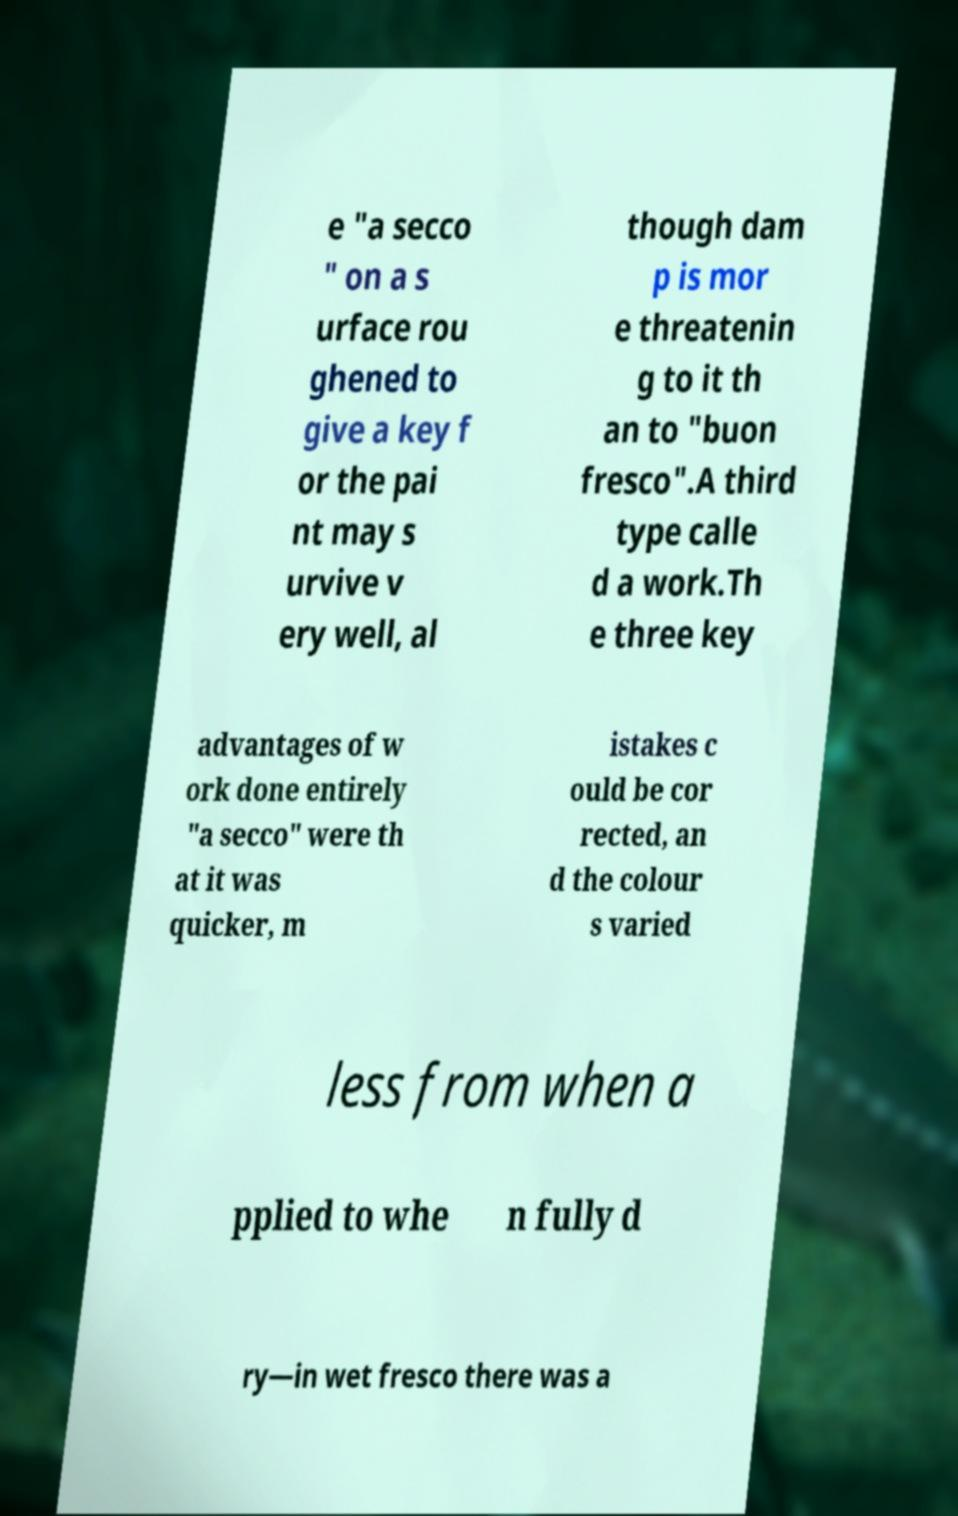There's text embedded in this image that I need extracted. Can you transcribe it verbatim? e "a secco " on a s urface rou ghened to give a key f or the pai nt may s urvive v ery well, al though dam p is mor e threatenin g to it th an to "buon fresco".A third type calle d a work.Th e three key advantages of w ork done entirely "a secco" were th at it was quicker, m istakes c ould be cor rected, an d the colour s varied less from when a pplied to whe n fully d ry—in wet fresco there was a 